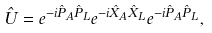<formula> <loc_0><loc_0><loc_500><loc_500>\hat { U } = e ^ { - i \hat { P } _ { A } \hat { P } _ { L } } e ^ { - i \hat { X } _ { A } \hat { X } _ { L } } e ^ { - i \hat { P } _ { A } \hat { P } _ { L } } ,</formula> 